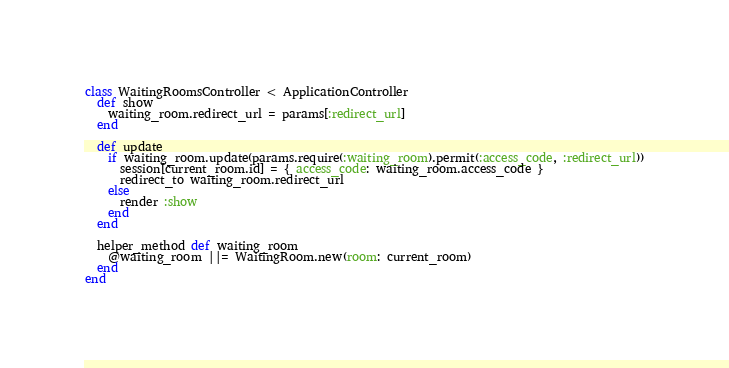Convert code to text. <code><loc_0><loc_0><loc_500><loc_500><_Ruby_>class WaitingRoomsController < ApplicationController
  def show
    waiting_room.redirect_url = params[:redirect_url]
  end

  def update
    if waiting_room.update(params.require(:waiting_room).permit(:access_code, :redirect_url))
      session[current_room.id] = { access_code: waiting_room.access_code }
      redirect_to waiting_room.redirect_url
    else
      render :show
    end
  end

  helper_method def waiting_room
    @waiting_room ||= WaitingRoom.new(room: current_room)
  end
end
</code> 